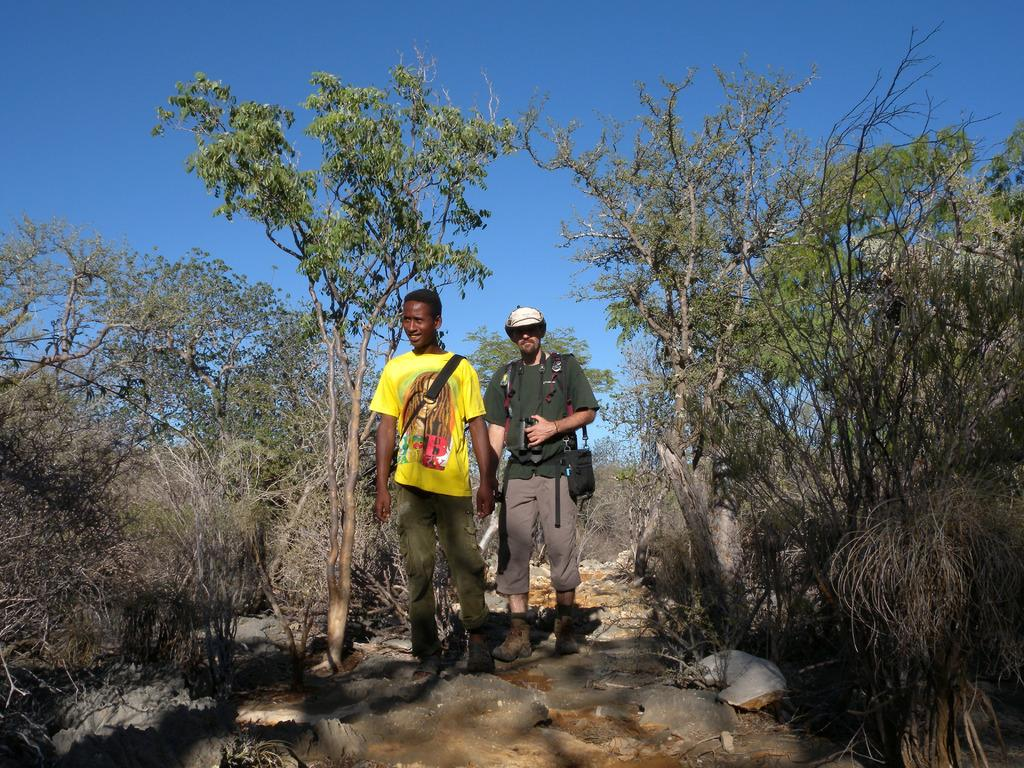How many people are in the image? There are two men in the image. What are the men doing in the image? The men are walking in the image. What are the men carrying while walking? The men are carrying bags in the image. What type of natural elements can be seen in the image? Trees and rocks are visible in the image. What is visible in the background of the image? The sky is visible in the background of the image. What is the color of the sky in the image? The color of the sky is blue in the image. Is the father of the men in the image also present? There is no indication in the image that the men have a father present, nor is there any mention of a father in the provided facts. Are the men at the seashore in the image? There is no indication in the image that the men are at the seashore, nor is there any mention of a seashore in the provided facts. 